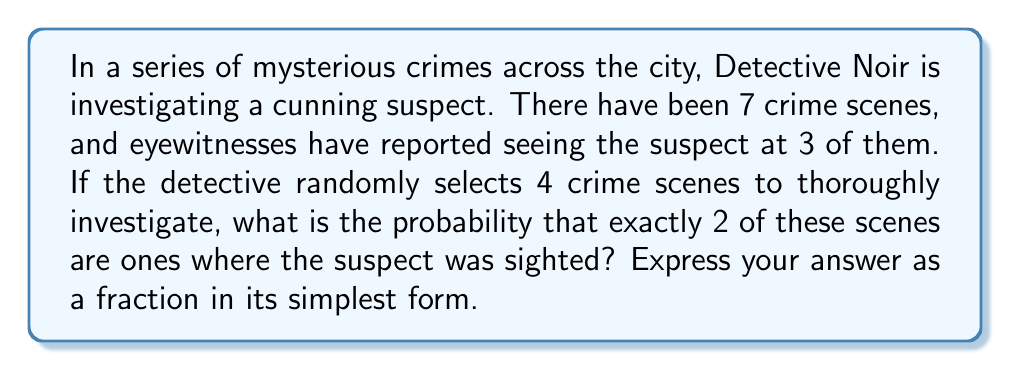Could you help me with this problem? Let's approach this step-by-step using combinatorics:

1) First, we need to calculate the number of ways to select 2 crime scenes where the suspect was sighted out of the 3 known scenes:
   $$\binom{3}{2} = \frac{3!}{2!(3-2)!} = \frac{3 \cdot 2}{2 \cdot 1} = 3$$

2) Next, we need to calculate the number of ways to select 2 crime scenes where the suspect was not sighted out of the 4 remaining scenes:
   $$\binom{4}{2} = \frac{4!}{2!(4-2)!} = \frac{4 \cdot 3}{2 \cdot 1} = 6$$

3) The total number of favorable outcomes is the product of these two:
   $$3 \cdot 6 = 18$$

4) Now, we need to calculate the total number of ways to select 4 crime scenes out of 7:
   $$\binom{7}{4} = \frac{7!}{4!(7-4)!} = \frac{7 \cdot 6 \cdot 5 \cdot 4}{4 \cdot 3 \cdot 2 \cdot 1} = 35$$

5) The probability is the number of favorable outcomes divided by the total number of possible outcomes:
   $$P(\text{exactly 2 sighted scenes}) = \frac{18}{35}$$

This fraction is already in its simplest form.
Answer: $\frac{18}{35}$ 